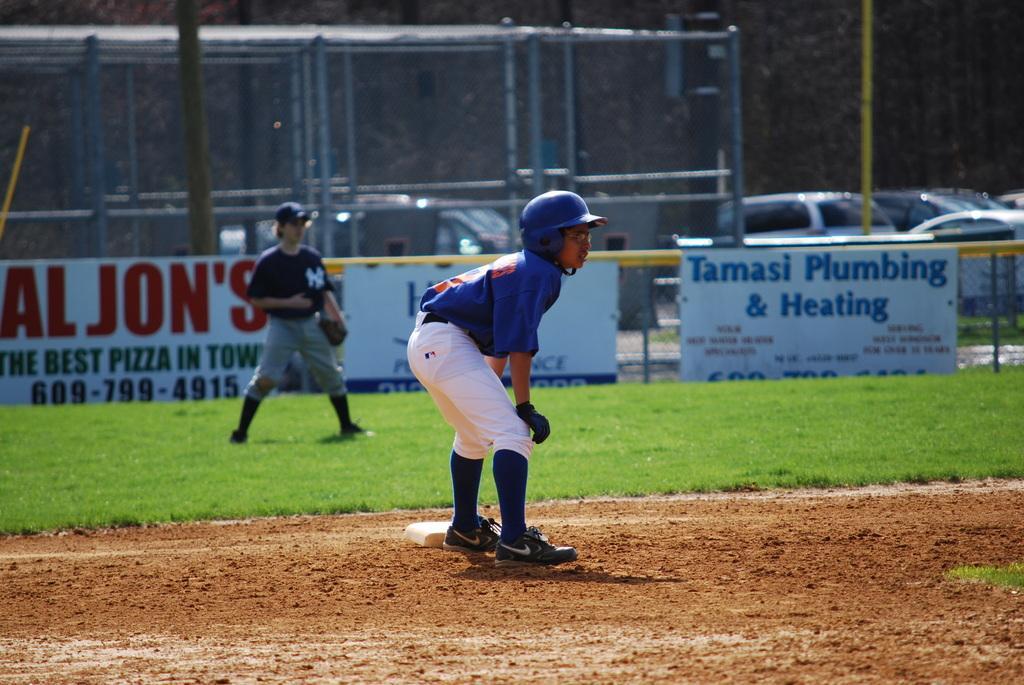Could you give a brief overview of what you see in this image? In this picture we can see there are two kids standing. Behind the kids there are boards, vehicles and those are looking like trees and the fence. 